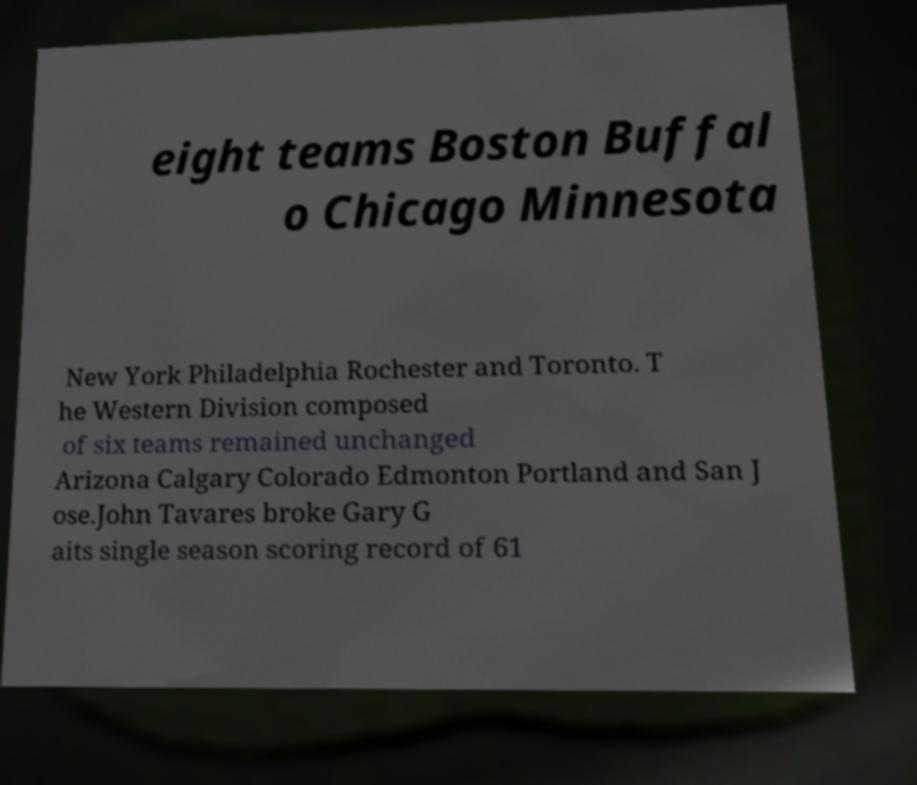What messages or text are displayed in this image? I need them in a readable, typed format. eight teams Boston Buffal o Chicago Minnesota New York Philadelphia Rochester and Toronto. T he Western Division composed of six teams remained unchanged Arizona Calgary Colorado Edmonton Portland and San J ose.John Tavares broke Gary G aits single season scoring record of 61 